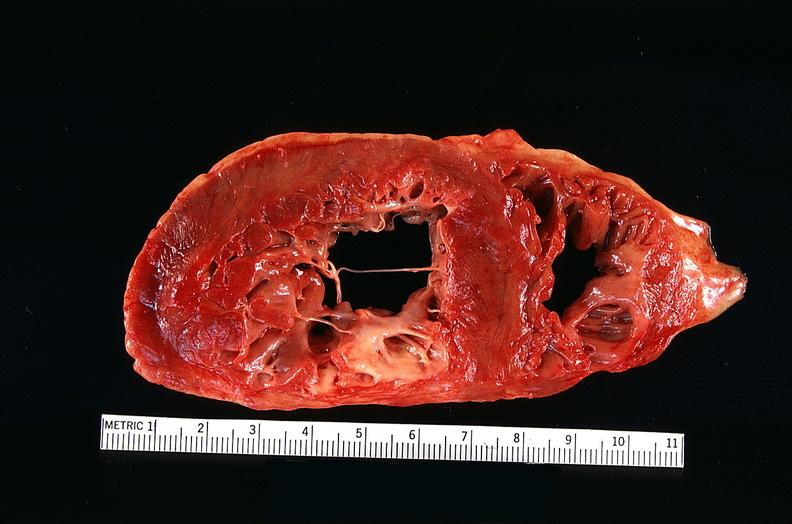does this image show congestive heart failure, three vessel coronary artery disease?
Answer the question using a single word or phrase. Yes 